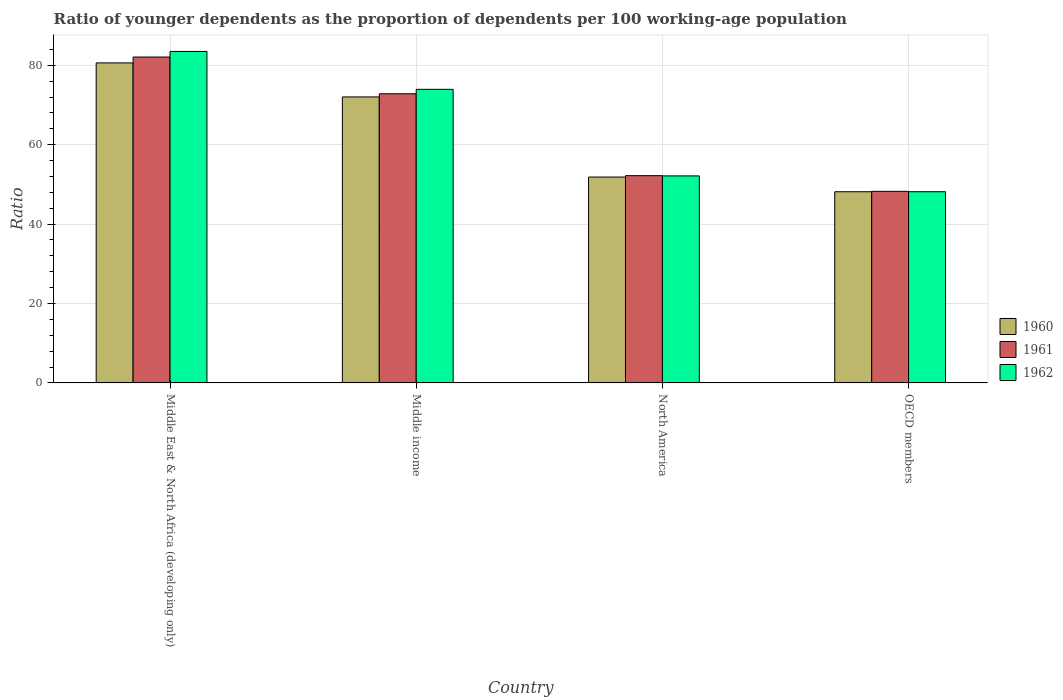How many different coloured bars are there?
Offer a very short reply. 3. Are the number of bars per tick equal to the number of legend labels?
Your answer should be compact. Yes. Are the number of bars on each tick of the X-axis equal?
Make the answer very short. Yes. How many bars are there on the 4th tick from the left?
Give a very brief answer. 3. What is the label of the 1st group of bars from the left?
Make the answer very short. Middle East & North Africa (developing only). What is the age dependency ratio(young) in 1961 in North America?
Make the answer very short. 52.2. Across all countries, what is the maximum age dependency ratio(young) in 1960?
Your response must be concise. 80.59. Across all countries, what is the minimum age dependency ratio(young) in 1960?
Provide a short and direct response. 48.15. In which country was the age dependency ratio(young) in 1960 maximum?
Your response must be concise. Middle East & North Africa (developing only). In which country was the age dependency ratio(young) in 1962 minimum?
Provide a succinct answer. OECD members. What is the total age dependency ratio(young) in 1961 in the graph?
Your answer should be very brief. 255.33. What is the difference between the age dependency ratio(young) in 1960 in North America and that in OECD members?
Provide a succinct answer. 3.7. What is the difference between the age dependency ratio(young) in 1960 in North America and the age dependency ratio(young) in 1962 in OECD members?
Your answer should be very brief. 3.7. What is the average age dependency ratio(young) in 1961 per country?
Offer a terse response. 63.83. What is the difference between the age dependency ratio(young) of/in 1961 and age dependency ratio(young) of/in 1962 in Middle income?
Offer a terse response. -1.12. What is the ratio of the age dependency ratio(young) in 1962 in Middle East & North Africa (developing only) to that in North America?
Ensure brevity in your answer.  1.6. Is the difference between the age dependency ratio(young) in 1961 in North America and OECD members greater than the difference between the age dependency ratio(young) in 1962 in North America and OECD members?
Ensure brevity in your answer.  No. What is the difference between the highest and the second highest age dependency ratio(young) in 1960?
Your answer should be very brief. 28.74. What is the difference between the highest and the lowest age dependency ratio(young) in 1960?
Your answer should be very brief. 32.44. Is the sum of the age dependency ratio(young) in 1961 in Middle East & North Africa (developing only) and Middle income greater than the maximum age dependency ratio(young) in 1960 across all countries?
Your answer should be very brief. Yes. How many bars are there?
Provide a short and direct response. 12. Are all the bars in the graph horizontal?
Your answer should be very brief. No. How many countries are there in the graph?
Give a very brief answer. 4. Does the graph contain grids?
Offer a very short reply. Yes. How are the legend labels stacked?
Give a very brief answer. Vertical. What is the title of the graph?
Provide a short and direct response. Ratio of younger dependents as the proportion of dependents per 100 working-age population. Does "2011" appear as one of the legend labels in the graph?
Your answer should be compact. No. What is the label or title of the X-axis?
Make the answer very short. Country. What is the label or title of the Y-axis?
Your answer should be compact. Ratio. What is the Ratio of 1960 in Middle East & North Africa (developing only)?
Keep it short and to the point. 80.59. What is the Ratio of 1961 in Middle East & North Africa (developing only)?
Ensure brevity in your answer.  82.07. What is the Ratio in 1962 in Middle East & North Africa (developing only)?
Provide a short and direct response. 83.47. What is the Ratio in 1960 in Middle income?
Ensure brevity in your answer.  72.02. What is the Ratio in 1961 in Middle income?
Your answer should be very brief. 72.82. What is the Ratio of 1962 in Middle income?
Ensure brevity in your answer.  73.93. What is the Ratio in 1960 in North America?
Make the answer very short. 51.85. What is the Ratio in 1961 in North America?
Keep it short and to the point. 52.2. What is the Ratio of 1962 in North America?
Offer a terse response. 52.13. What is the Ratio of 1960 in OECD members?
Offer a very short reply. 48.15. What is the Ratio of 1961 in OECD members?
Ensure brevity in your answer.  48.25. What is the Ratio of 1962 in OECD members?
Your response must be concise. 48.15. Across all countries, what is the maximum Ratio of 1960?
Your response must be concise. 80.59. Across all countries, what is the maximum Ratio of 1961?
Give a very brief answer. 82.07. Across all countries, what is the maximum Ratio in 1962?
Your response must be concise. 83.47. Across all countries, what is the minimum Ratio of 1960?
Ensure brevity in your answer.  48.15. Across all countries, what is the minimum Ratio of 1961?
Give a very brief answer. 48.25. Across all countries, what is the minimum Ratio of 1962?
Offer a very short reply. 48.15. What is the total Ratio in 1960 in the graph?
Ensure brevity in your answer.  252.6. What is the total Ratio of 1961 in the graph?
Keep it short and to the point. 255.33. What is the total Ratio of 1962 in the graph?
Give a very brief answer. 257.69. What is the difference between the Ratio in 1960 in Middle East & North Africa (developing only) and that in Middle income?
Give a very brief answer. 8.57. What is the difference between the Ratio in 1961 in Middle East & North Africa (developing only) and that in Middle income?
Your response must be concise. 9.25. What is the difference between the Ratio in 1962 in Middle East & North Africa (developing only) and that in Middle income?
Give a very brief answer. 9.54. What is the difference between the Ratio in 1960 in Middle East & North Africa (developing only) and that in North America?
Provide a short and direct response. 28.74. What is the difference between the Ratio of 1961 in Middle East & North Africa (developing only) and that in North America?
Make the answer very short. 29.87. What is the difference between the Ratio of 1962 in Middle East & North Africa (developing only) and that in North America?
Your answer should be compact. 31.34. What is the difference between the Ratio of 1960 in Middle East & North Africa (developing only) and that in OECD members?
Make the answer very short. 32.45. What is the difference between the Ratio of 1961 in Middle East & North Africa (developing only) and that in OECD members?
Offer a very short reply. 33.82. What is the difference between the Ratio in 1962 in Middle East & North Africa (developing only) and that in OECD members?
Provide a short and direct response. 35.32. What is the difference between the Ratio of 1960 in Middle income and that in North America?
Ensure brevity in your answer.  20.17. What is the difference between the Ratio in 1961 in Middle income and that in North America?
Offer a terse response. 20.62. What is the difference between the Ratio of 1962 in Middle income and that in North America?
Offer a very short reply. 21.8. What is the difference between the Ratio in 1960 in Middle income and that in OECD members?
Provide a short and direct response. 23.87. What is the difference between the Ratio in 1961 in Middle income and that in OECD members?
Offer a terse response. 24.57. What is the difference between the Ratio of 1962 in Middle income and that in OECD members?
Keep it short and to the point. 25.78. What is the difference between the Ratio in 1960 in North America and that in OECD members?
Offer a terse response. 3.7. What is the difference between the Ratio in 1961 in North America and that in OECD members?
Ensure brevity in your answer.  3.95. What is the difference between the Ratio of 1962 in North America and that in OECD members?
Offer a very short reply. 3.98. What is the difference between the Ratio in 1960 in Middle East & North Africa (developing only) and the Ratio in 1961 in Middle income?
Ensure brevity in your answer.  7.77. What is the difference between the Ratio in 1960 in Middle East & North Africa (developing only) and the Ratio in 1962 in Middle income?
Offer a terse response. 6.66. What is the difference between the Ratio of 1961 in Middle East & North Africa (developing only) and the Ratio of 1962 in Middle income?
Give a very brief answer. 8.14. What is the difference between the Ratio in 1960 in Middle East & North Africa (developing only) and the Ratio in 1961 in North America?
Your response must be concise. 28.39. What is the difference between the Ratio of 1960 in Middle East & North Africa (developing only) and the Ratio of 1962 in North America?
Keep it short and to the point. 28.46. What is the difference between the Ratio of 1961 in Middle East & North Africa (developing only) and the Ratio of 1962 in North America?
Ensure brevity in your answer.  29.93. What is the difference between the Ratio in 1960 in Middle East & North Africa (developing only) and the Ratio in 1961 in OECD members?
Give a very brief answer. 32.34. What is the difference between the Ratio in 1960 in Middle East & North Africa (developing only) and the Ratio in 1962 in OECD members?
Your response must be concise. 32.44. What is the difference between the Ratio in 1961 in Middle East & North Africa (developing only) and the Ratio in 1962 in OECD members?
Offer a very short reply. 33.92. What is the difference between the Ratio of 1960 in Middle income and the Ratio of 1961 in North America?
Offer a terse response. 19.82. What is the difference between the Ratio in 1960 in Middle income and the Ratio in 1962 in North America?
Make the answer very short. 19.89. What is the difference between the Ratio of 1961 in Middle income and the Ratio of 1962 in North America?
Ensure brevity in your answer.  20.68. What is the difference between the Ratio in 1960 in Middle income and the Ratio in 1961 in OECD members?
Provide a succinct answer. 23.77. What is the difference between the Ratio in 1960 in Middle income and the Ratio in 1962 in OECD members?
Keep it short and to the point. 23.87. What is the difference between the Ratio in 1961 in Middle income and the Ratio in 1962 in OECD members?
Provide a short and direct response. 24.66. What is the difference between the Ratio of 1960 in North America and the Ratio of 1961 in OECD members?
Your answer should be very brief. 3.6. What is the difference between the Ratio of 1960 in North America and the Ratio of 1962 in OECD members?
Provide a short and direct response. 3.7. What is the difference between the Ratio in 1961 in North America and the Ratio in 1962 in OECD members?
Keep it short and to the point. 4.04. What is the average Ratio of 1960 per country?
Provide a succinct answer. 63.15. What is the average Ratio of 1961 per country?
Keep it short and to the point. 63.83. What is the average Ratio of 1962 per country?
Make the answer very short. 64.42. What is the difference between the Ratio in 1960 and Ratio in 1961 in Middle East & North Africa (developing only)?
Keep it short and to the point. -1.48. What is the difference between the Ratio of 1960 and Ratio of 1962 in Middle East & North Africa (developing only)?
Your response must be concise. -2.88. What is the difference between the Ratio of 1961 and Ratio of 1962 in Middle East & North Africa (developing only)?
Keep it short and to the point. -1.4. What is the difference between the Ratio in 1960 and Ratio in 1961 in Middle income?
Offer a terse response. -0.8. What is the difference between the Ratio of 1960 and Ratio of 1962 in Middle income?
Offer a terse response. -1.91. What is the difference between the Ratio of 1961 and Ratio of 1962 in Middle income?
Provide a short and direct response. -1.12. What is the difference between the Ratio of 1960 and Ratio of 1961 in North America?
Provide a succinct answer. -0.35. What is the difference between the Ratio of 1960 and Ratio of 1962 in North America?
Provide a short and direct response. -0.29. What is the difference between the Ratio in 1961 and Ratio in 1962 in North America?
Offer a terse response. 0.06. What is the difference between the Ratio in 1960 and Ratio in 1961 in OECD members?
Offer a terse response. -0.1. What is the difference between the Ratio of 1960 and Ratio of 1962 in OECD members?
Make the answer very short. -0.01. What is the difference between the Ratio in 1961 and Ratio in 1962 in OECD members?
Give a very brief answer. 0.09. What is the ratio of the Ratio of 1960 in Middle East & North Africa (developing only) to that in Middle income?
Make the answer very short. 1.12. What is the ratio of the Ratio of 1961 in Middle East & North Africa (developing only) to that in Middle income?
Provide a succinct answer. 1.13. What is the ratio of the Ratio of 1962 in Middle East & North Africa (developing only) to that in Middle income?
Your answer should be very brief. 1.13. What is the ratio of the Ratio of 1960 in Middle East & North Africa (developing only) to that in North America?
Keep it short and to the point. 1.55. What is the ratio of the Ratio of 1961 in Middle East & North Africa (developing only) to that in North America?
Offer a terse response. 1.57. What is the ratio of the Ratio in 1962 in Middle East & North Africa (developing only) to that in North America?
Provide a short and direct response. 1.6. What is the ratio of the Ratio in 1960 in Middle East & North Africa (developing only) to that in OECD members?
Provide a short and direct response. 1.67. What is the ratio of the Ratio of 1961 in Middle East & North Africa (developing only) to that in OECD members?
Your response must be concise. 1.7. What is the ratio of the Ratio of 1962 in Middle East & North Africa (developing only) to that in OECD members?
Provide a short and direct response. 1.73. What is the ratio of the Ratio in 1960 in Middle income to that in North America?
Provide a short and direct response. 1.39. What is the ratio of the Ratio in 1961 in Middle income to that in North America?
Provide a succinct answer. 1.4. What is the ratio of the Ratio in 1962 in Middle income to that in North America?
Ensure brevity in your answer.  1.42. What is the ratio of the Ratio in 1960 in Middle income to that in OECD members?
Provide a short and direct response. 1.5. What is the ratio of the Ratio of 1961 in Middle income to that in OECD members?
Your answer should be very brief. 1.51. What is the ratio of the Ratio of 1962 in Middle income to that in OECD members?
Offer a very short reply. 1.54. What is the ratio of the Ratio in 1961 in North America to that in OECD members?
Your response must be concise. 1.08. What is the ratio of the Ratio of 1962 in North America to that in OECD members?
Your answer should be compact. 1.08. What is the difference between the highest and the second highest Ratio in 1960?
Offer a very short reply. 8.57. What is the difference between the highest and the second highest Ratio of 1961?
Your answer should be very brief. 9.25. What is the difference between the highest and the second highest Ratio in 1962?
Give a very brief answer. 9.54. What is the difference between the highest and the lowest Ratio in 1960?
Provide a succinct answer. 32.45. What is the difference between the highest and the lowest Ratio of 1961?
Give a very brief answer. 33.82. What is the difference between the highest and the lowest Ratio of 1962?
Provide a short and direct response. 35.32. 